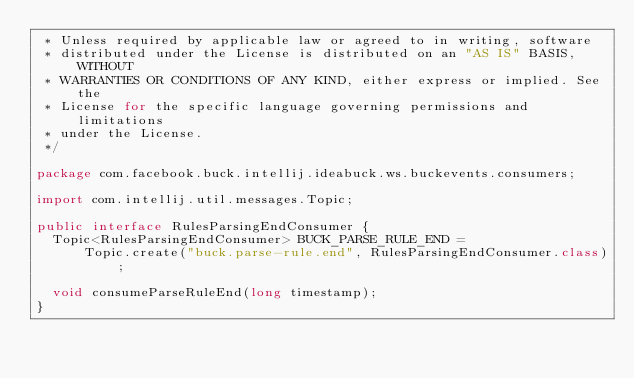Convert code to text. <code><loc_0><loc_0><loc_500><loc_500><_Java_> * Unless required by applicable law or agreed to in writing, software
 * distributed under the License is distributed on an "AS IS" BASIS, WITHOUT
 * WARRANTIES OR CONDITIONS OF ANY KIND, either express or implied. See the
 * License for the specific language governing permissions and limitations
 * under the License.
 */

package com.facebook.buck.intellij.ideabuck.ws.buckevents.consumers;

import com.intellij.util.messages.Topic;

public interface RulesParsingEndConsumer {
  Topic<RulesParsingEndConsumer> BUCK_PARSE_RULE_END =
      Topic.create("buck.parse-rule.end", RulesParsingEndConsumer.class);

  void consumeParseRuleEnd(long timestamp);
}
</code> 